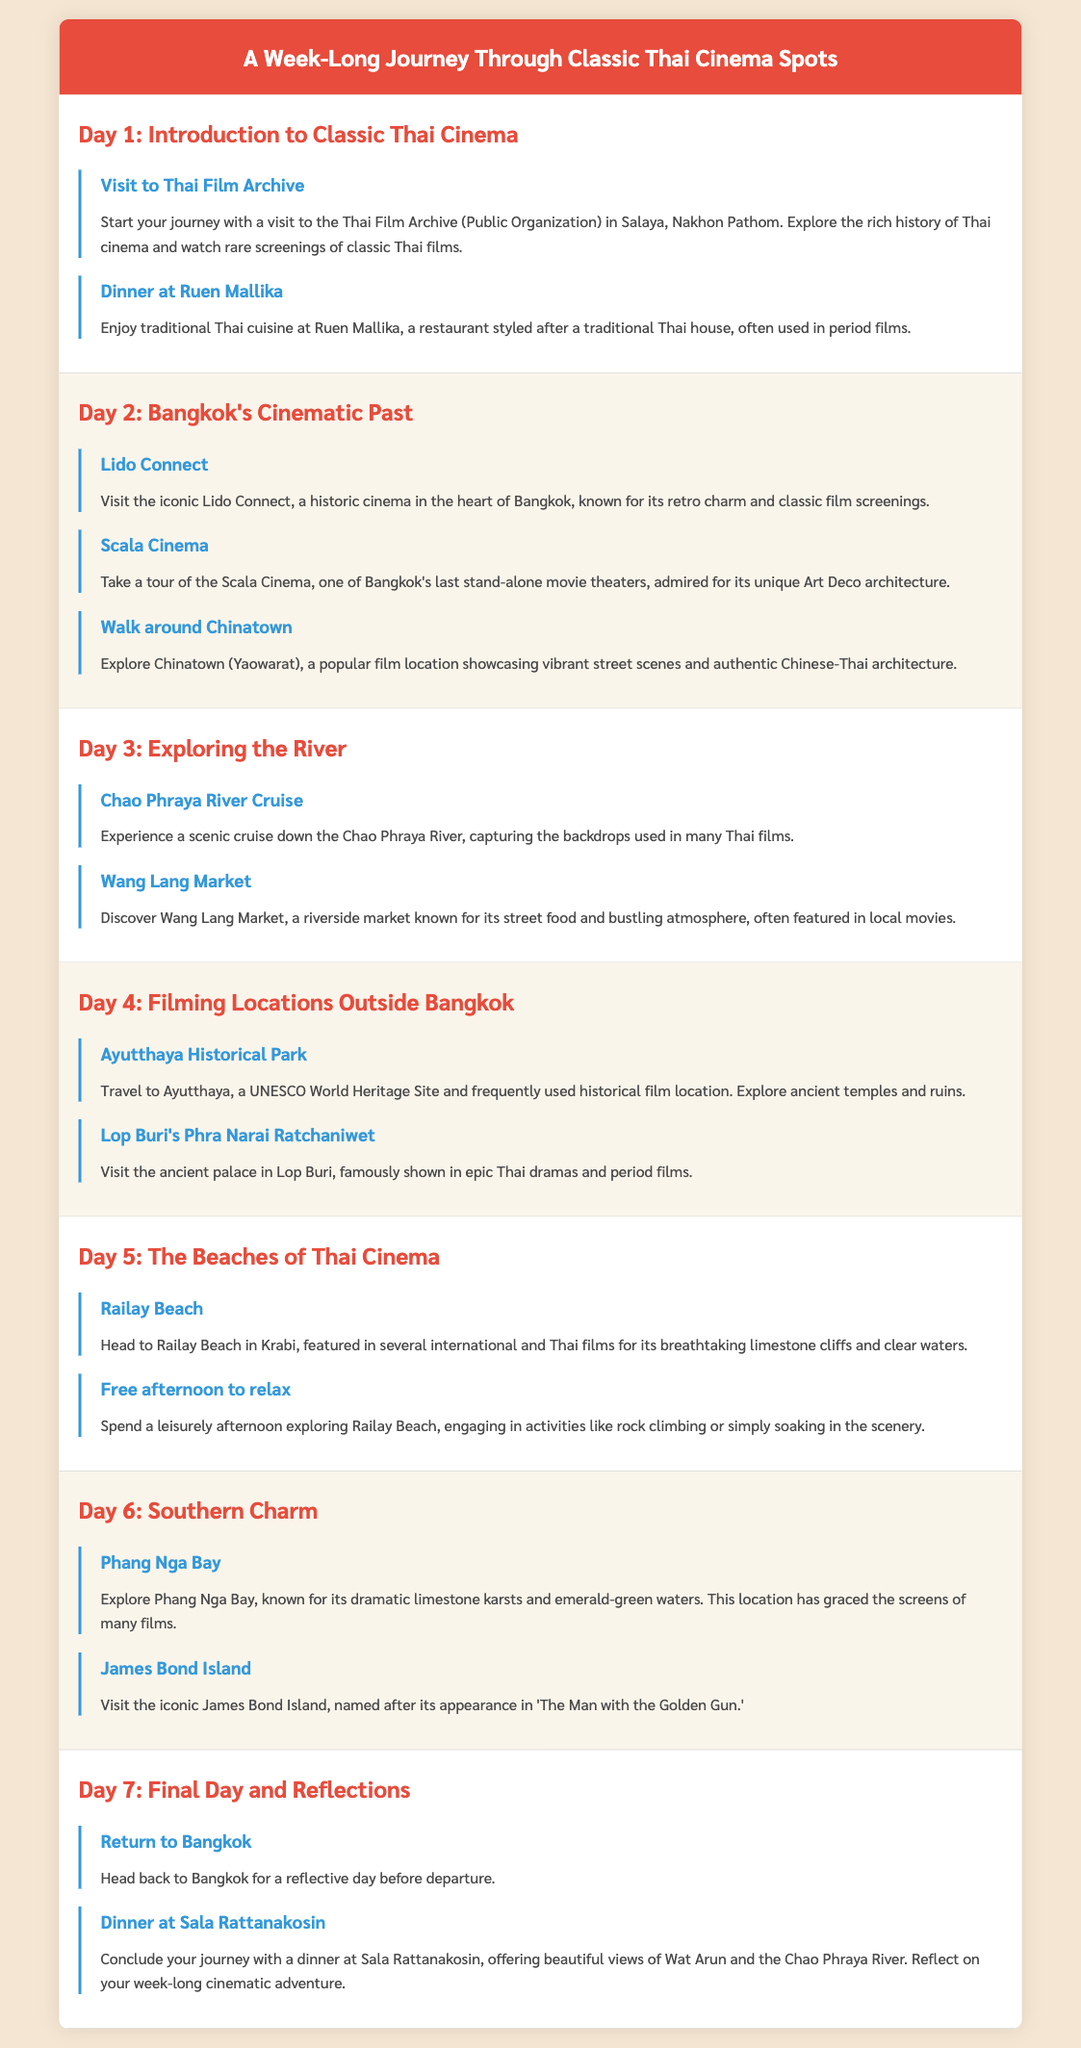What is the first location to visit on Day 1? The first location listed is the Thai Film Archive (Public Organization) in Salaya, Nakhon Pathom.
Answer: Thai Film Archive How many days are included in the itinerary? The itinerary outlines activities for a total of seven days.
Answer: 7 What is one activity planned for Day 2? One activity for Day 2 is visiting the Scala Cinema.
Answer: Scala Cinema Which historical site is mentioned for Day 4? The ancient palace in Lop Buri, famously shown in epic Thai dramas, is mentioned.
Answer: Lop Buri's Phra Narai Ratchaniwet What feature distinguishes the Lido Connect cinema? Lido Connect is known for its retro charm and classic film screenings.
Answer: Retro charm What scenic location is featured on Day 5? Railay Beach is featured on Day 5, known for its breathtaking limestone cliffs.
Answer: Railay Beach What key theme is highlighted throughout the itinerary? The theme focuses on classic Thai cinema spots and iconic film locations.
Answer: Classic Thai cinema What is the final dinner location mentioned in the itinerary? The final dinner location is Sala Rattanakosin.
Answer: Sala Rattanakosin 